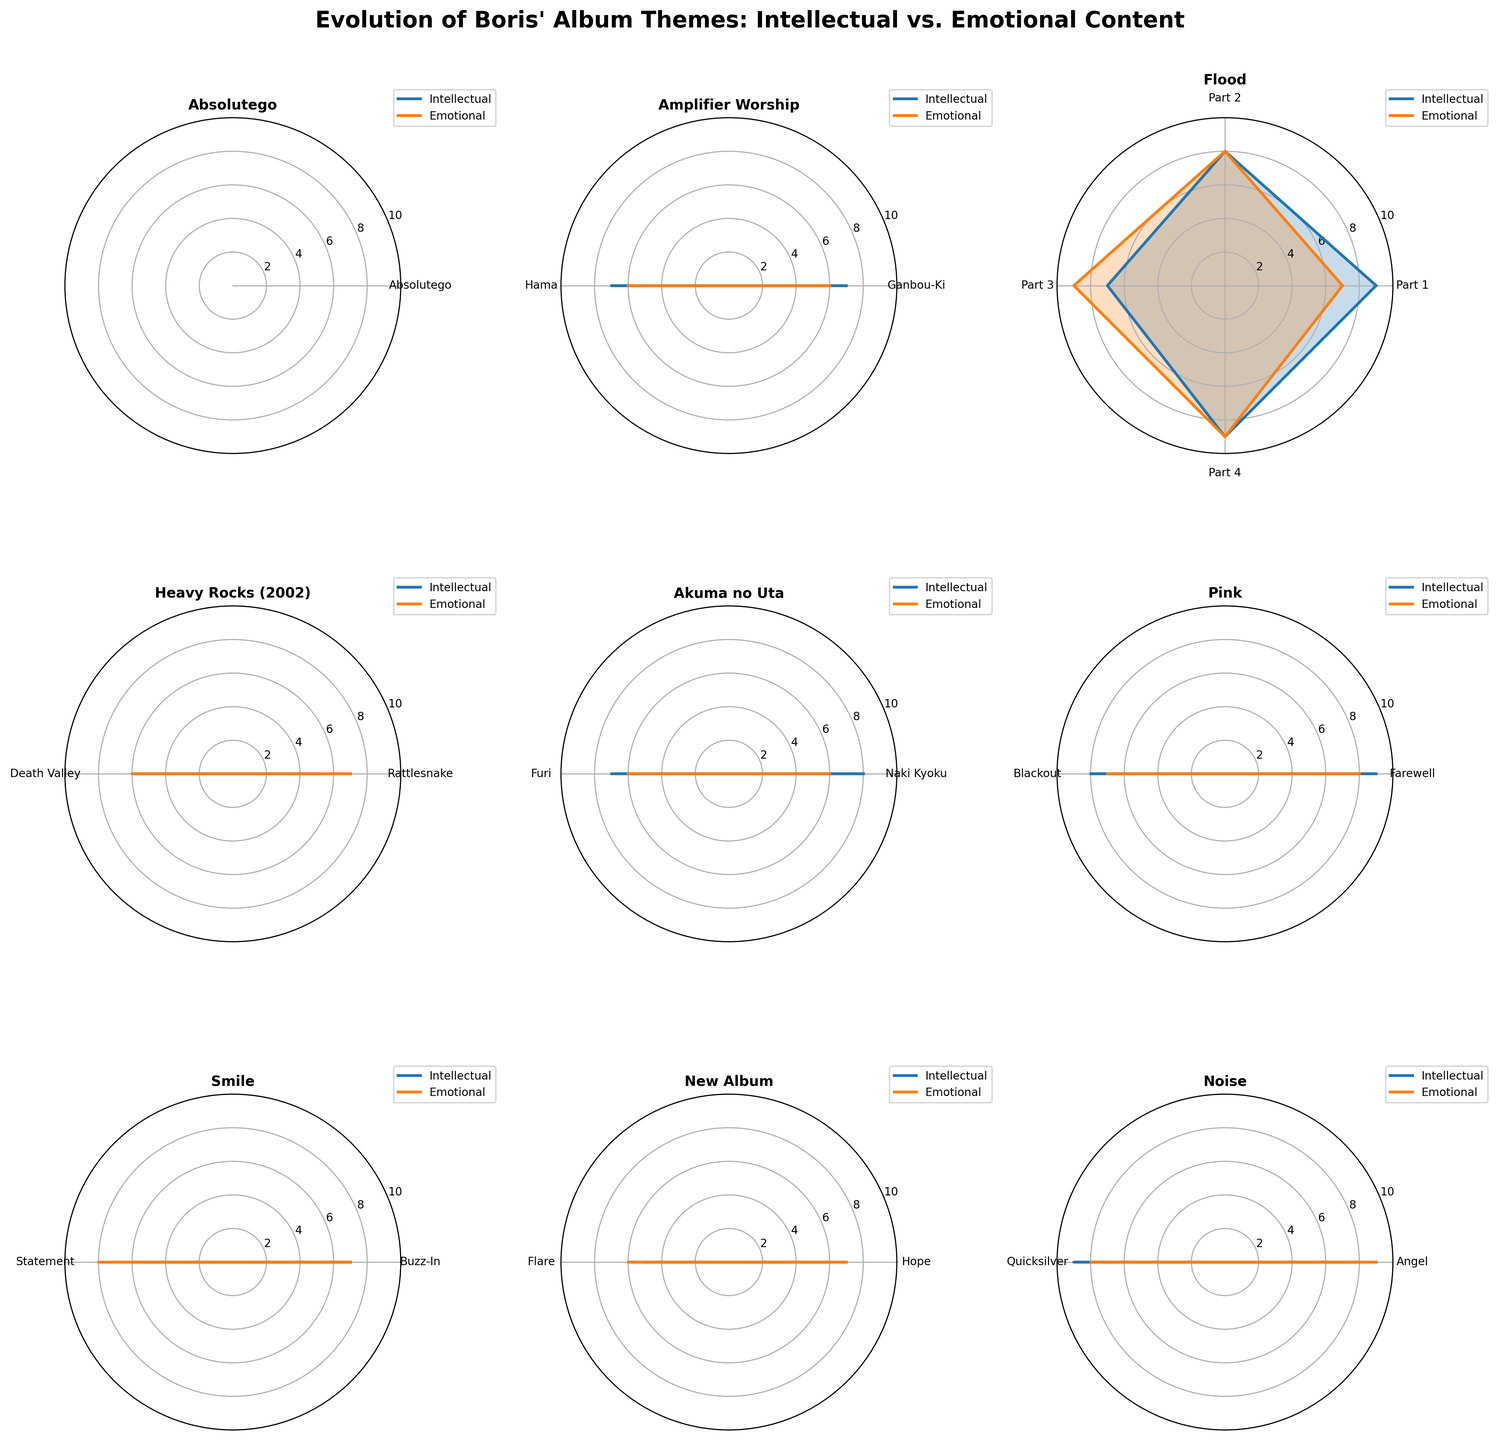What's the title of the figure? The title of the figure is written at the top and indicates the main subject of the plot.
Answer: Evolution of Boris' Album Themes: Intellectual vs. Emotional Content How many albums are visualized in the figure? The figure uses subplots to visualize individual albums, and the total number can be counted by looking at the titles of the subplots.
Answer: 9 Which album has the highest Emotional content among all tracks combined? By looking at the Emotional axis values across all subplots and finding the highest one, we can determine which album has the highest Emotional content. "Flood" has a significant presence of high Emotional values across its tracks.
Answer: Flood Which album shows the most balance between Intellectual and Emotional content? To determine balance, one should look for albums where the plots for Intellectual and Emotional closely overlap, indicating similar values for both themes. "LφVE & EVφL (2020)" shows a strong balance as the lines for both themes are close to each other across tracks.
Answer: LφVE & EVφL (2020) What is the highest Intellectual content value recorded across all albums? Look for the highest peak in the Intellectual values across all subplots. The highest value recorded is for "Flood" and "Pink".
Answer: 9 Which album has the track with the lowest Intellectual content value? Identify the lowest point in the Intellectual axis across all subplots. "New Album" and "Heavy Rocks (2002)" have tracks with the lowest Intellectual content value of 5.
Answer: New Album and Heavy Rocks (2002) On which album does the track "Farewell" appear, what are its Intellectual and Emotional values? Check the subplot titles and track labels to find the specific track "Farewell," and note its corresponding Intellectual and Emotional values. It appears on "Pink" with values of 9 (Intellectual) and 8 (Emotional).
Answer: Pink, 9, 8 Which albums have tracks that show Emotional content values of 9? Check the Emotional values for each track across all subplots. "Flood" and "Noise" have tracks with an Emotional value of 9.
Answer: Flood and Noise Which album contains the most tracks? Count the number of tracks (angles) in each subplot to determine which album has the most.
Answer: Flood What's the difference between Intellectual and Emotional content for the track "Hama"? Identify the subplot for "Amplifier Worship," find the track "Hama," and calculate the difference between Intellectual and Emotional values. For "Hama," the Intellectual value is 7 and Emotional is 6, so the difference is 1.
Answer: 1 